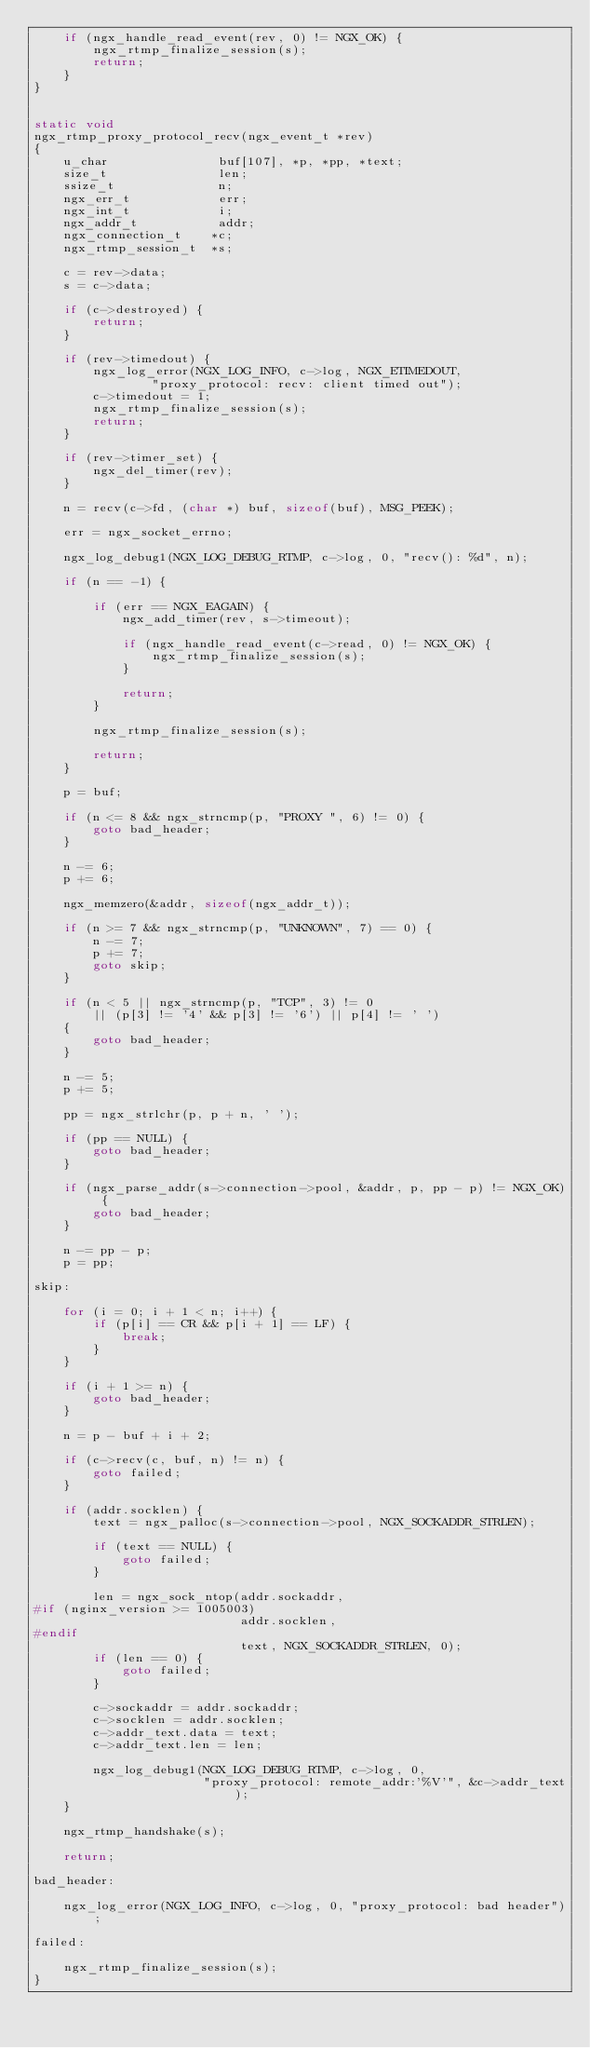<code> <loc_0><loc_0><loc_500><loc_500><_C_>    if (ngx_handle_read_event(rev, 0) != NGX_OK) {
        ngx_rtmp_finalize_session(s);
        return;
    }
}


static void
ngx_rtmp_proxy_protocol_recv(ngx_event_t *rev)
{
    u_char               buf[107], *p, *pp, *text;
    size_t               len;
    ssize_t              n;
    ngx_err_t            err;
    ngx_int_t            i;
    ngx_addr_t           addr;
    ngx_connection_t    *c;
    ngx_rtmp_session_t  *s;

    c = rev->data;
    s = c->data;

    if (c->destroyed) {
        return;
    }

    if (rev->timedout) {
        ngx_log_error(NGX_LOG_INFO, c->log, NGX_ETIMEDOUT,
                "proxy_protocol: recv: client timed out");
        c->timedout = 1;
        ngx_rtmp_finalize_session(s);
        return;
    }

    if (rev->timer_set) {
        ngx_del_timer(rev);
    }

    n = recv(c->fd, (char *) buf, sizeof(buf), MSG_PEEK);

    err = ngx_socket_errno;

    ngx_log_debug1(NGX_LOG_DEBUG_RTMP, c->log, 0, "recv(): %d", n);

    if (n == -1) {

        if (err == NGX_EAGAIN) {
            ngx_add_timer(rev, s->timeout);

            if (ngx_handle_read_event(c->read, 0) != NGX_OK) {
                ngx_rtmp_finalize_session(s);
            }

            return;
        }

        ngx_rtmp_finalize_session(s);

        return;
    }

    p = buf;

    if (n <= 8 && ngx_strncmp(p, "PROXY ", 6) != 0) {
        goto bad_header;
    }

    n -= 6;
    p += 6;

    ngx_memzero(&addr, sizeof(ngx_addr_t));

    if (n >= 7 && ngx_strncmp(p, "UNKNOWN", 7) == 0) {
        n -= 7;
        p += 7;
        goto skip;
    }

    if (n < 5 || ngx_strncmp(p, "TCP", 3) != 0
        || (p[3] != '4' && p[3] != '6') || p[4] != ' ')
    {
        goto bad_header;
    }

    n -= 5;
    p += 5;

    pp = ngx_strlchr(p, p + n, ' ');

    if (pp == NULL) {
        goto bad_header;
    }

    if (ngx_parse_addr(s->connection->pool, &addr, p, pp - p) != NGX_OK) {
        goto bad_header;
    }

    n -= pp - p;
    p = pp;

skip:

    for (i = 0; i + 1 < n; i++) {
        if (p[i] == CR && p[i + 1] == LF) {
            break;
        }
    }

    if (i + 1 >= n) {
        goto bad_header;
    }

    n = p - buf + i + 2;

    if (c->recv(c, buf, n) != n) {
        goto failed;
    }

    if (addr.socklen) {
        text = ngx_palloc(s->connection->pool, NGX_SOCKADDR_STRLEN);

        if (text == NULL) {
            goto failed;
        }

        len = ngx_sock_ntop(addr.sockaddr,
#if (nginx_version >= 1005003)
                            addr.socklen,
#endif
                            text, NGX_SOCKADDR_STRLEN, 0);
        if (len == 0) {
            goto failed;
        }

        c->sockaddr = addr.sockaddr;
        c->socklen = addr.socklen;
        c->addr_text.data = text;
        c->addr_text.len = len;

        ngx_log_debug1(NGX_LOG_DEBUG_RTMP, c->log, 0,
                       "proxy_protocol: remote_addr:'%V'", &c->addr_text);
    }

    ngx_rtmp_handshake(s);

    return;

bad_header:

    ngx_log_error(NGX_LOG_INFO, c->log, 0, "proxy_protocol: bad header");

failed:

    ngx_rtmp_finalize_session(s);
}
</code> 